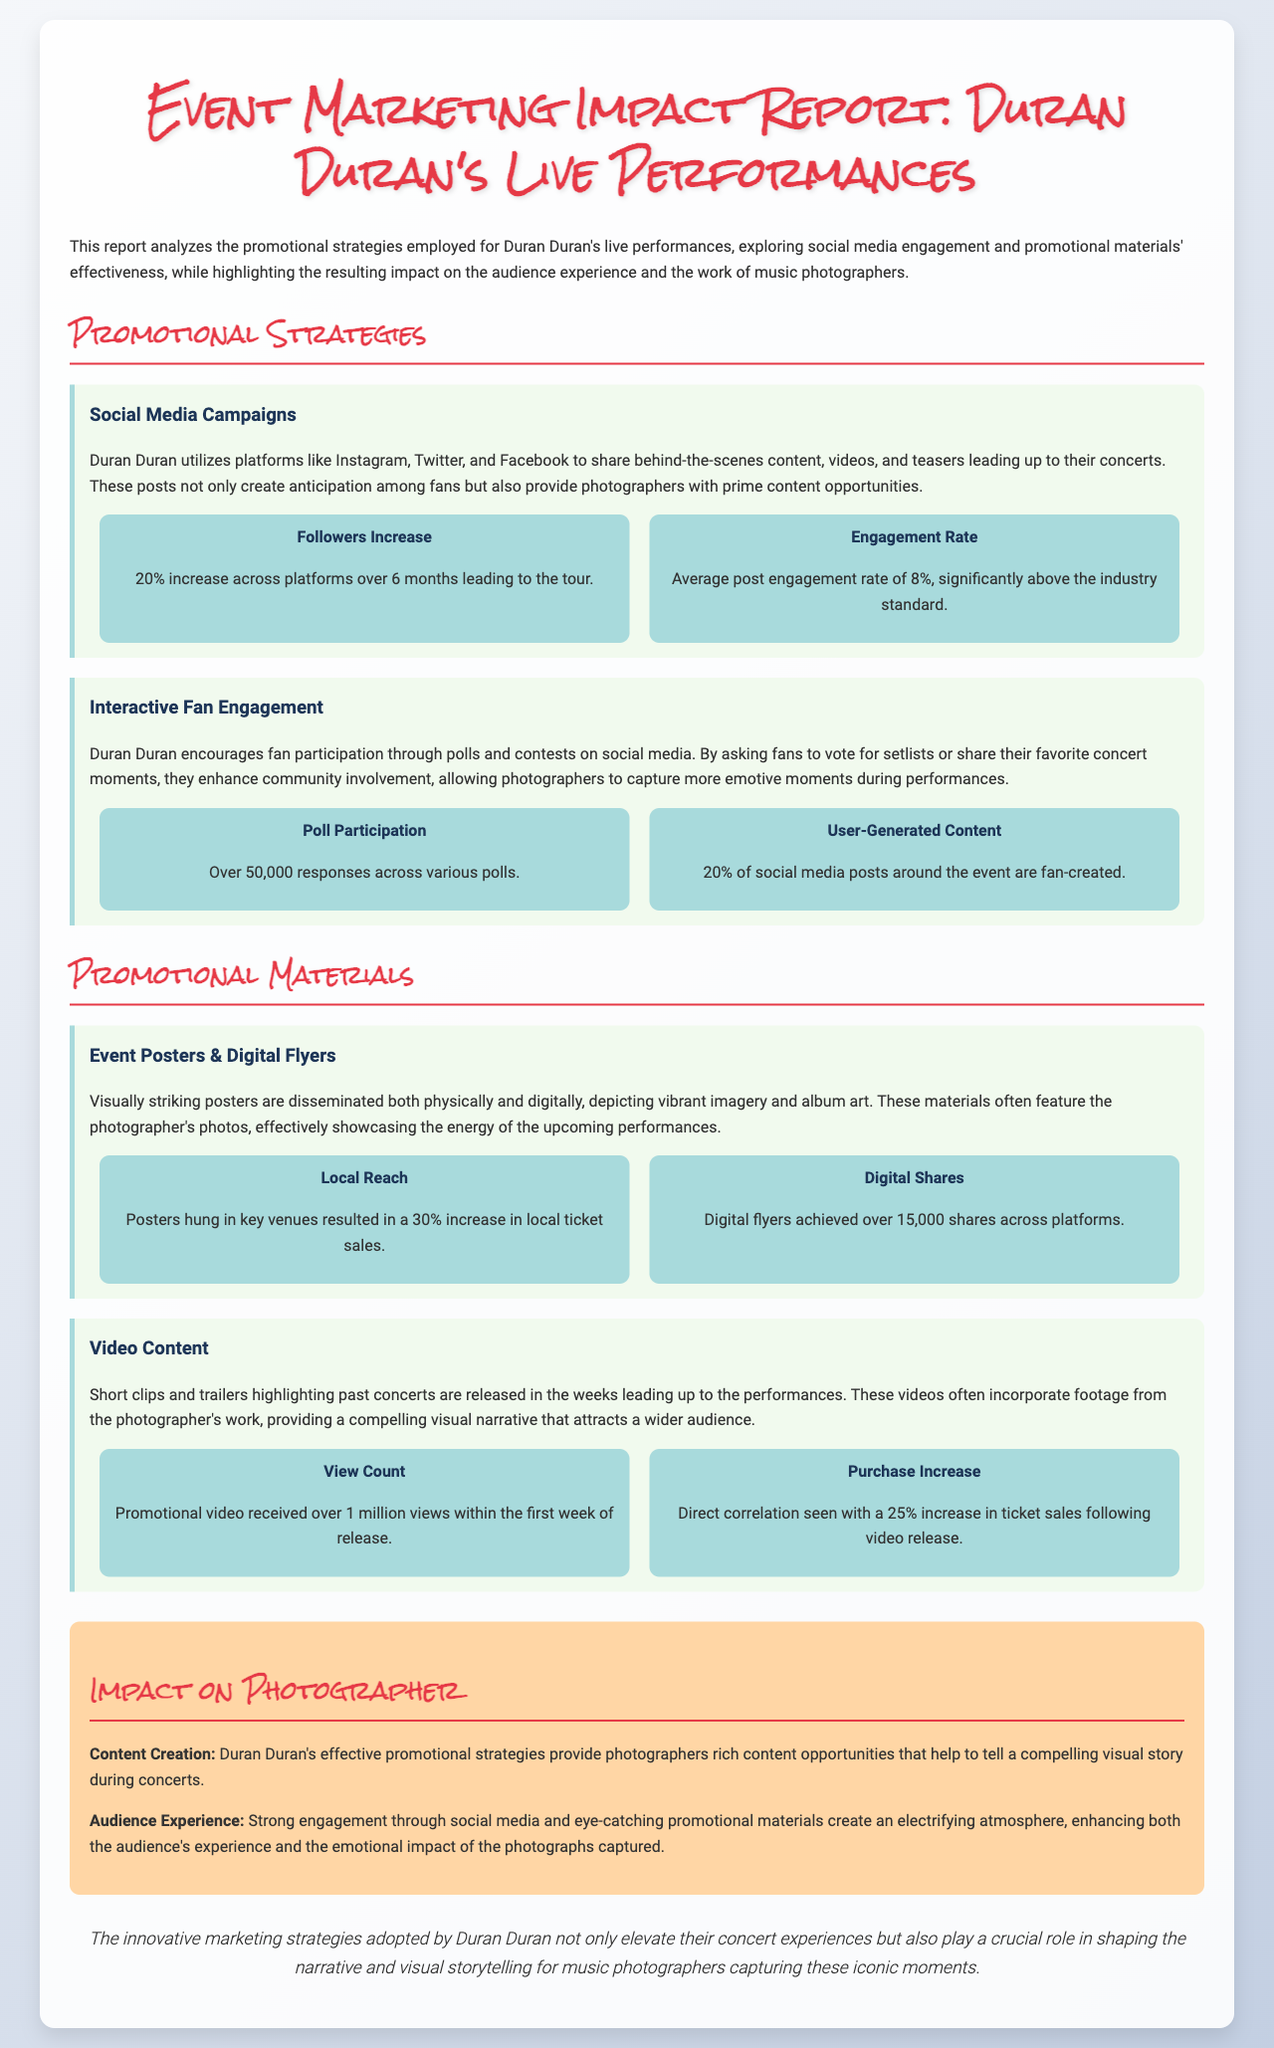What was the increase in followers across social media platforms over six months? The document states that there was a 20% increase in followers across platforms over six months leading to the tour.
Answer: 20% What was the average post engagement rate? The document mentions that the average post engagement rate is 8%, which is significantly above the industry standard.
Answer: 8% How many responses were received for various polls? The report notes that there were over 50,000 responses across various polls.
Answer: Over 50,000 What was the local ticket sales increase attributed to posters? The document indicates that posters hung in key venues resulted in a 30% increase in local ticket sales.
Answer: 30% What is the view count for the promotional video released? According to the report, the promotional video received over 1 million views within the first week of release.
Answer: Over 1 million How does audience engagement impact the photographer's work? The document explains that strong engagement creates an electrifying atmosphere, enhancing the emotional impact of the photographs captured.
Answer: Electrifying atmosphere What percentage of social media posts around the event are fan-created? The report states that 20% of social media posts around the event are fan-created.
Answer: 20% What was the purchase increase related to video content? The document reveals a direct correlation with a 25% increase in ticket sales following the video release.
Answer: 25% What materials feature the photographer's photos? The document mentions that event posters and digital flyers often feature the photographer's photos.
Answer: Event posters and digital flyers 